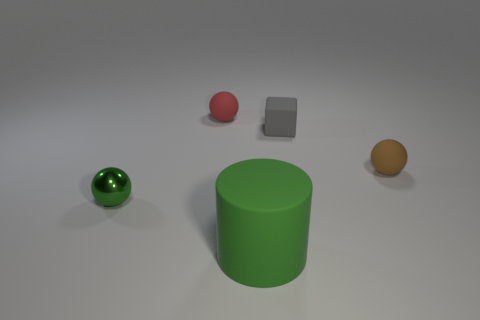Subtract all tiny brown balls. How many balls are left? 2 Add 1 green things. How many objects exist? 6 Subtract all spheres. How many objects are left? 2 Add 5 tiny blue metal cylinders. How many tiny blue metal cylinders exist? 5 Subtract 0 blue cylinders. How many objects are left? 5 Subtract all spheres. Subtract all large objects. How many objects are left? 1 Add 5 tiny blocks. How many tiny blocks are left? 6 